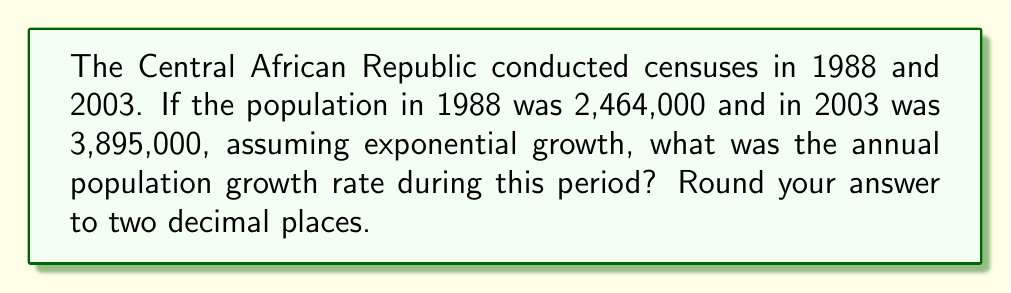What is the answer to this math problem? To solve this inverse problem and determine the population growth rate from the given census data, we'll use the exponential growth formula and work backwards. Let's follow these steps:

1) The exponential growth formula is:
   $$P(t) = P_0 e^{rt}$$
   where $P(t)$ is the population at time $t$, $P_0$ is the initial population, $r$ is the growth rate, and $t$ is the time period.

2) We know:
   $P_0 = 2,464,000$ (1988 population)
   $P(t) = 3,895,000$ (2003 population)
   $t = 15$ years (from 1988 to 2003)

3) Substituting these values into the formula:
   $$3,895,000 = 2,464,000 e^{15r}$$

4) Divide both sides by 2,464,000:
   $$\frac{3,895,000}{2,464,000} = e^{15r}$$

5) Take the natural logarithm of both sides:
   $$\ln(\frac{3,895,000}{2,464,000}) = 15r$$

6) Solve for $r$:
   $$r = \frac{\ln(\frac{3,895,000}{2,464,000})}{15}$$

7) Calculate:
   $$r = \frac{\ln(1.5807)}{15} = \frac{0.4579}{15} = 0.03053$$

8) Convert to a percentage and round to two decimal places:
   $r = 3.05\%$
Answer: 3.05% 